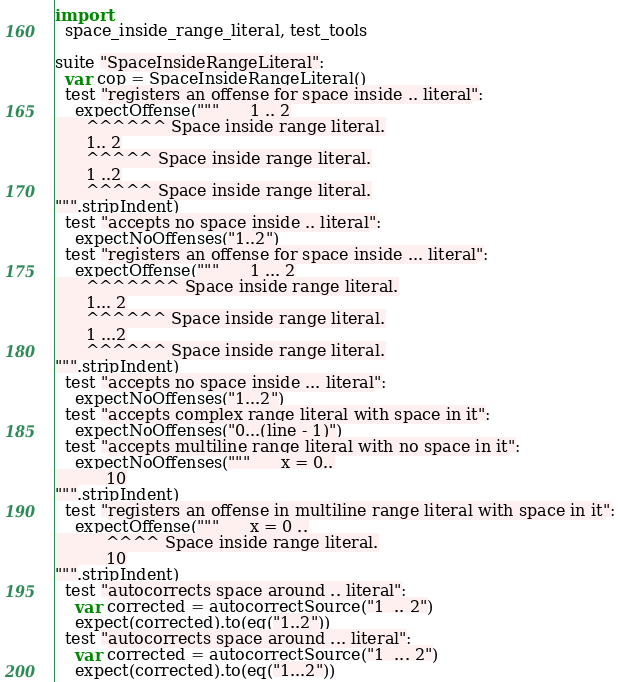<code> <loc_0><loc_0><loc_500><loc_500><_Nim_>
import
  space_inside_range_literal, test_tools

suite "SpaceInsideRangeLiteral":
  var cop = SpaceInsideRangeLiteral()
  test "registers an offense for space inside .. literal":
    expectOffense("""      1 .. 2
      ^^^^^^ Space inside range literal.
      1.. 2
      ^^^^^ Space inside range literal.
      1 ..2
      ^^^^^ Space inside range literal.
""".stripIndent)
  test "accepts no space inside .. literal":
    expectNoOffenses("1..2")
  test "registers an offense for space inside ... literal":
    expectOffense("""      1 ... 2
      ^^^^^^^ Space inside range literal.
      1... 2
      ^^^^^^ Space inside range literal.
      1 ...2
      ^^^^^^ Space inside range literal.
""".stripIndent)
  test "accepts no space inside ... literal":
    expectNoOffenses("1...2")
  test "accepts complex range literal with space in it":
    expectNoOffenses("0...(line - 1)")
  test "accepts multiline range literal with no space in it":
    expectNoOffenses("""      x = 0..
          10
""".stripIndent)
  test "registers an offense in multiline range literal with space in it":
    expectOffense("""      x = 0 ..
          ^^^^ Space inside range literal.
          10
""".stripIndent)
  test "autocorrects space around .. literal":
    var corrected = autocorrectSource("1  .. 2")
    expect(corrected).to(eq("1..2"))
  test "autocorrects space around ... literal":
    var corrected = autocorrectSource("1  ... 2")
    expect(corrected).to(eq("1...2"))
</code> 